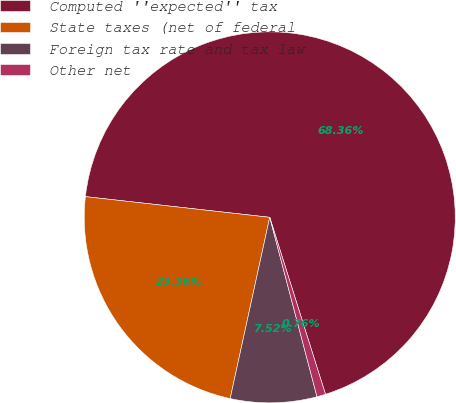<chart> <loc_0><loc_0><loc_500><loc_500><pie_chart><fcel>Computed ''expected'' tax<fcel>State taxes (net of federal<fcel>Foreign tax rate and tax law<fcel>Other net<nl><fcel>68.36%<fcel>23.36%<fcel>7.52%<fcel>0.76%<nl></chart> 